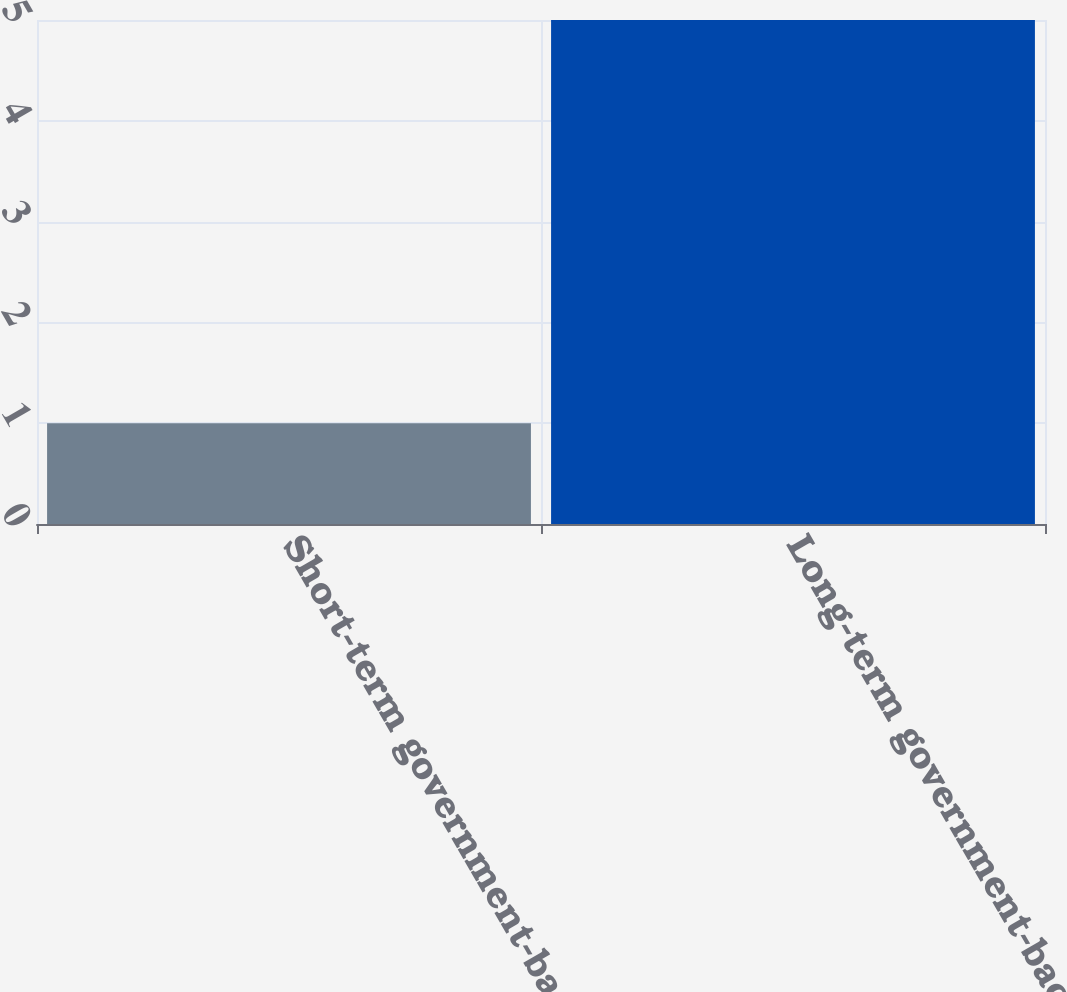<chart> <loc_0><loc_0><loc_500><loc_500><bar_chart><fcel>Short-term government-backed<fcel>Long-term government-backed<nl><fcel>1<fcel>5<nl></chart> 